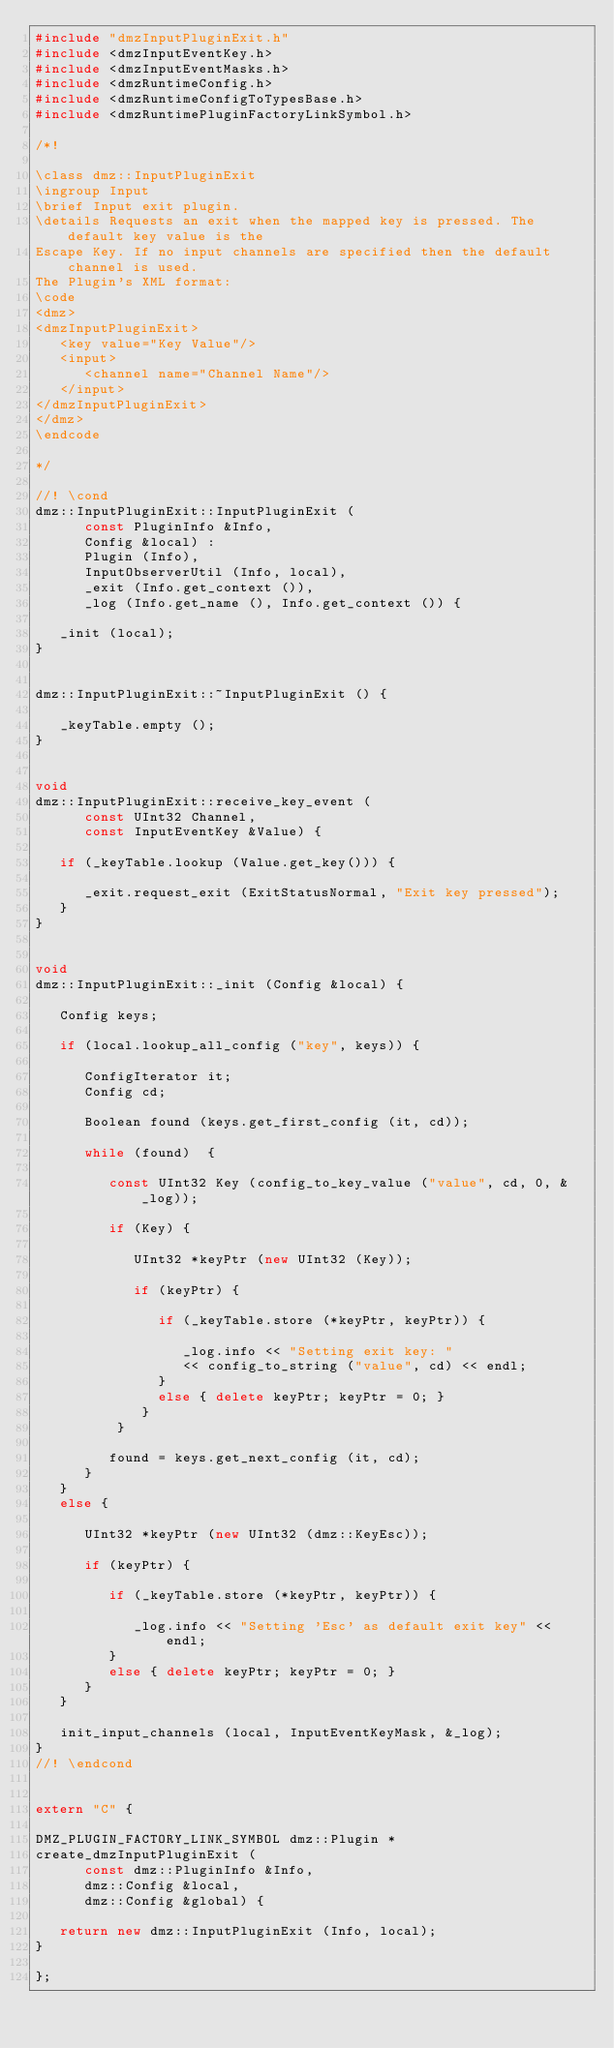<code> <loc_0><loc_0><loc_500><loc_500><_C++_>#include "dmzInputPluginExit.h"
#include <dmzInputEventKey.h>
#include <dmzInputEventMasks.h>
#include <dmzRuntimeConfig.h>
#include <dmzRuntimeConfigToTypesBase.h>
#include <dmzRuntimePluginFactoryLinkSymbol.h>

/*!

\class dmz::InputPluginExit
\ingroup Input
\brief Input exit plugin.
\details Requests an exit when the mapped key is pressed. The default key value is the
Escape Key. If no input channels are specified then the default channel is used.
The Plugin's XML format:
\code
<dmz>
<dmzInputPluginExit>
   <key value="Key Value"/>
   <input>
      <channel name="Channel Name"/>
   </input>
</dmzInputPluginExit>
</dmz>
\endcode

*/

//! \cond
dmz::InputPluginExit::InputPluginExit (
      const PluginInfo &Info,
      Config &local) :
      Plugin (Info),
      InputObserverUtil (Info, local),
      _exit (Info.get_context ()),
      _log (Info.get_name (), Info.get_context ()) {

   _init (local);
}


dmz::InputPluginExit::~InputPluginExit () {

   _keyTable.empty ();
}


void
dmz::InputPluginExit::receive_key_event (
      const UInt32 Channel,
      const InputEventKey &Value) {

   if (_keyTable.lookup (Value.get_key())) {

      _exit.request_exit (ExitStatusNormal, "Exit key pressed");
   }
}


void
dmz::InputPluginExit::_init (Config &local) {

   Config keys;

   if (local.lookup_all_config ("key", keys)) {

      ConfigIterator it;
      Config cd;

      Boolean found (keys.get_first_config (it, cd));

      while (found)  {

         const UInt32 Key (config_to_key_value ("value", cd, 0, &_log));

         if (Key) {

            UInt32 *keyPtr (new UInt32 (Key));

            if (keyPtr) {

               if (_keyTable.store (*keyPtr, keyPtr)) {

                  _log.info << "Setting exit key: "
                  << config_to_string ("value", cd) << endl;
               }
               else { delete keyPtr; keyPtr = 0; }
             }
          }

         found = keys.get_next_config (it, cd);
      }
   }
   else {

      UInt32 *keyPtr (new UInt32 (dmz::KeyEsc));

      if (keyPtr) {

         if (_keyTable.store (*keyPtr, keyPtr)) {

            _log.info << "Setting 'Esc' as default exit key" << endl;
         }
         else { delete keyPtr; keyPtr = 0; }
      }
   }

   init_input_channels (local, InputEventKeyMask, &_log);
}
//! \endcond


extern "C" {

DMZ_PLUGIN_FACTORY_LINK_SYMBOL dmz::Plugin *
create_dmzInputPluginExit (
      const dmz::PluginInfo &Info,
      dmz::Config &local,
      dmz::Config &global) {

   return new dmz::InputPluginExit (Info, local);
}

};
</code> 